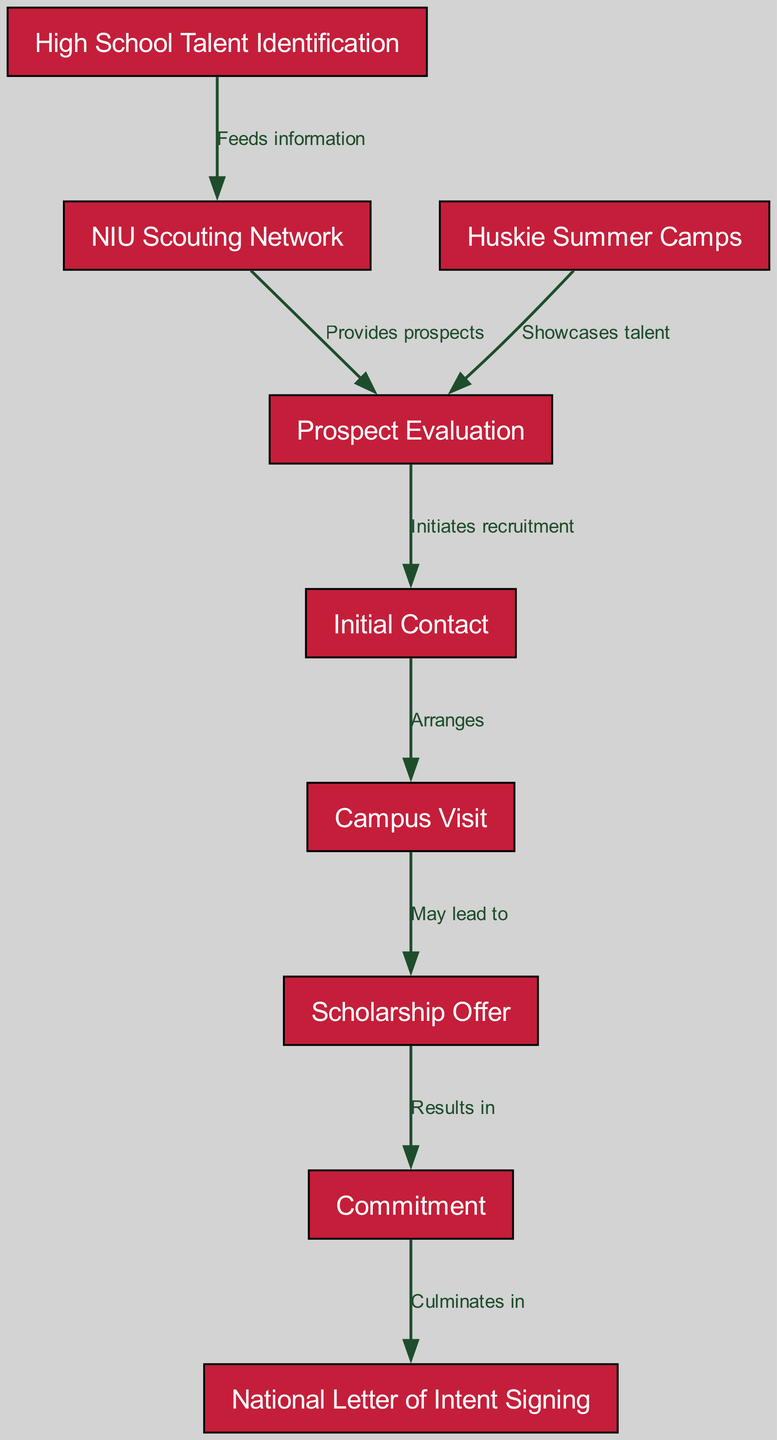What is the first step in the recruitment process? The diagram indicates that the first step is High School Talent Identification. This is the starting point where talent is identified before any scouting or evaluation occurs.
Answer: High School Talent Identification How many nodes are present in the diagram? By counting the individual nodes listed, we find there are a total of nine nodes representing different stages or steps in the recruitment process.
Answer: 9 What does the NIU Scouting Network provide? The edge from the NIU Scouting Network to Prospect Evaluation shows that it provides prospects, meaning it helps identify potential athletes for recruitment.
Answer: Provides prospects What are the last two steps in the recruitment process? The final connections in the diagram show Commitment leading to National Letter of Intent Signing, indicating that these are the last two activities that conclude the recruitment process.
Answer: Commitment, National Letter of Intent Signing What initiates recruitment after the Prospect Evaluation step? The edge between Prospect Evaluation and Initial Contact illustrates that the recruitment process is initiated once the evaluation is completed, prompting contact with the prospect.
Answer: Initial Contact What leads to a Scholarship Offer after campus visits? The arrow going from Campus Visit to Scholarship Offer implies that a campus visit may lead to an official scholarship offer for the recruited athlete if the visit is successful.
Answer: May lead to What is the relationship between Commitment and National Letter of Intent Signing? The diagram shows that Commitment culminates in signing the National Letter of Intent, meaning that making a commitment is a prerequisite for the signing step.
Answer: Culminates in Which node showcases talent? According to the diagram, Huskie Summer Camps are specifically mentioned as a node that showcases talent, allowing potential recruits to display their skills to the coaching staff.
Answer: Huskie Summer Camps What gives the information to the NIU Scouting Network? From the diagram, it can be seen that High School Talent Identification feeds information to the NIU Scouting Network, which utilizes this information to seek prospects.
Answer: Feeds information 